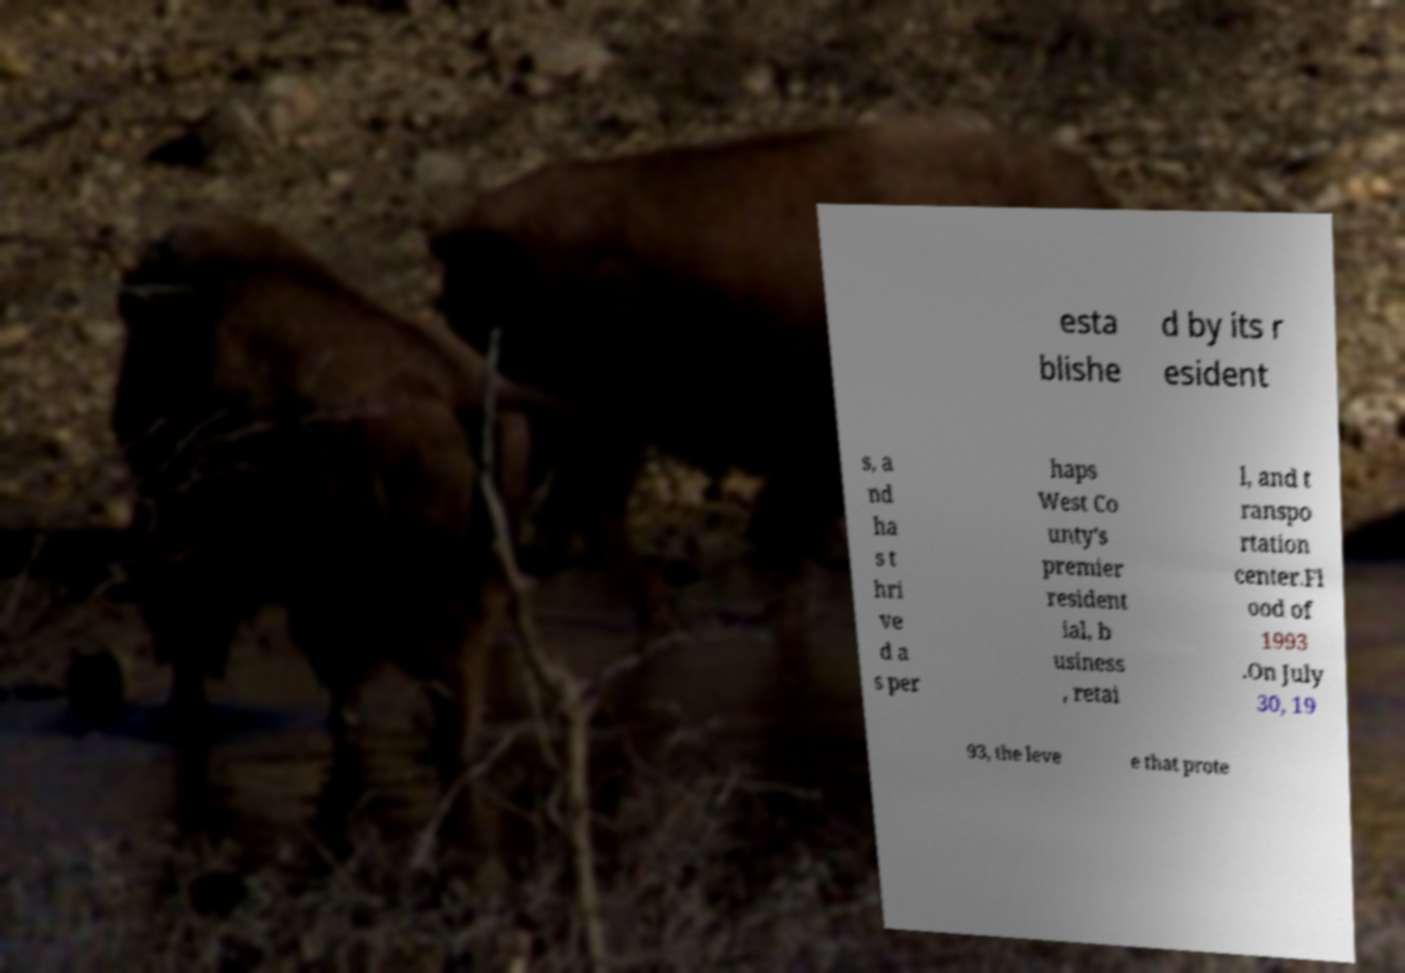There's text embedded in this image that I need extracted. Can you transcribe it verbatim? esta blishe d by its r esident s, a nd ha s t hri ve d a s per haps West Co unty's premier resident ial, b usiness , retai l, and t ranspo rtation center.Fl ood of 1993 .On July 30, 19 93, the leve e that prote 